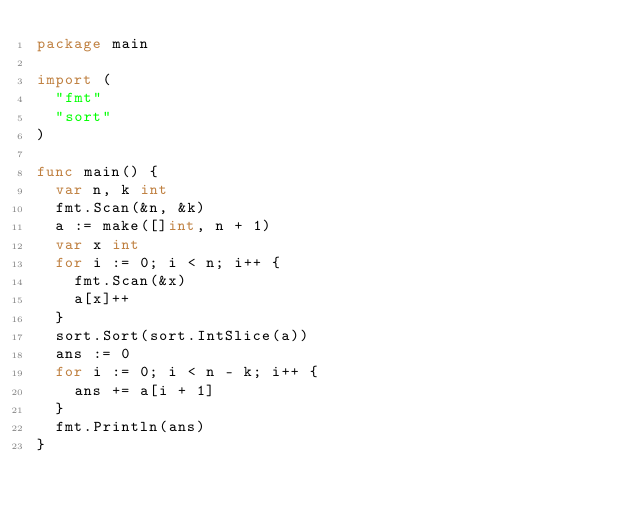<code> <loc_0><loc_0><loc_500><loc_500><_Go_>package main

import (
  "fmt"
  "sort"
)

func main() {
  var n, k int
  fmt.Scan(&n, &k)
  a := make([]int, n + 1)
  var x int
  for i := 0; i < n; i++ {
    fmt.Scan(&x)
    a[x]++
  }
  sort.Sort(sort.IntSlice(a))
  ans := 0
  for i := 0; i < n - k; i++ {
    ans += a[i + 1]
  }
  fmt.Println(ans)
}
</code> 